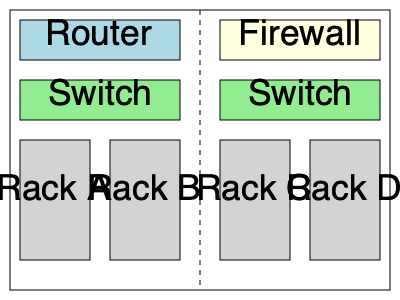Based on the network diagram provided, which server rack configuration would be most suitable for hosting the main web servers to ensure optimal performance and security during a local tech event? To determine the most suitable server rack configuration for hosting the main web servers during a local tech event, we need to consider several factors:

1. Network topology: The diagram shows a symmetrical network setup with a router and firewall at the top level, followed by switches and server racks.

2. Security: The firewall is placed on the right side of the network, indicating that traffic from the internet would likely pass through it first.

3. Performance: For optimal performance, we want to minimize the number of network hops between the internet-facing devices and the web servers.

4. Load distribution: It's best to spread the load across multiple racks for redundancy and better performance.

Given these considerations:

1. Racks C and D are closer to the firewall, which provides better security for incoming traffic.
2. Using both Racks C and D allows for load distribution and redundancy.
3. The proximity to the firewall and switch on the right side minimizes network hops, potentially improving performance.

Therefore, the most suitable configuration would be to use both Rack C and Rack D for hosting the main web servers. This setup provides a balance of security, performance, and load distribution, which is crucial for a successful tech event.
Answer: Racks C and D 